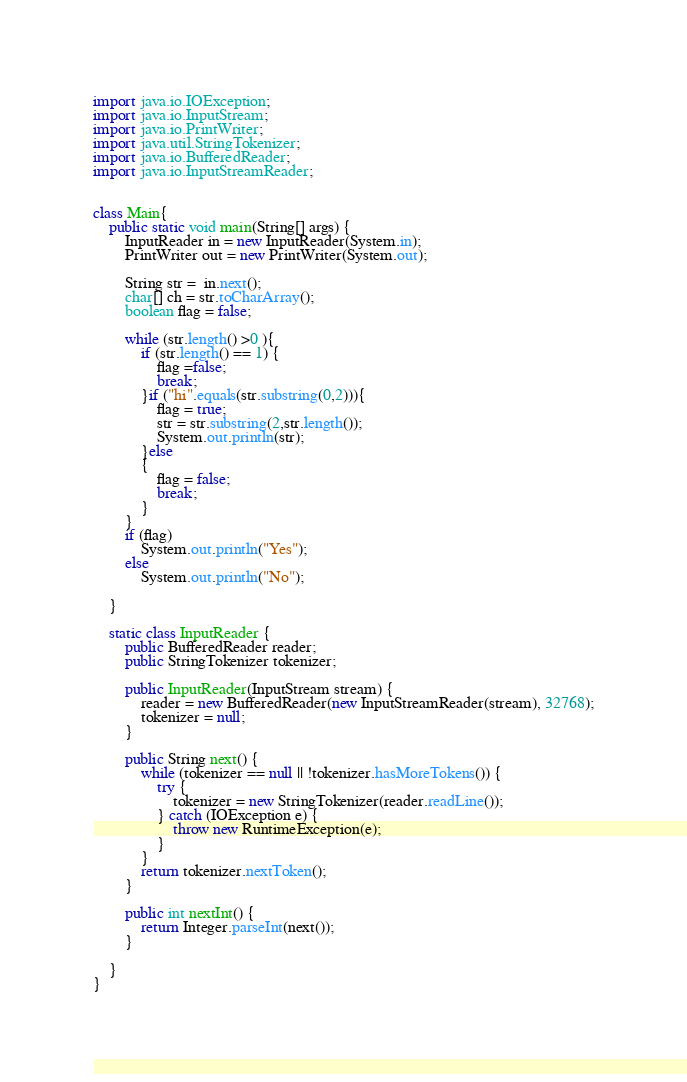<code> <loc_0><loc_0><loc_500><loc_500><_Java_>
import java.io.IOException;
import java.io.InputStream;
import java.io.PrintWriter;
import java.util.StringTokenizer;
import java.io.BufferedReader;
import java.io.InputStreamReader;


class Main{
    public static void main(String[] args) {
        InputReader in = new InputReader(System.in);
        PrintWriter out = new PrintWriter(System.out);

        String str =  in.next();
        char[] ch = str.toCharArray();
        boolean flag = false;

        while (str.length() >0 ){
            if (str.length() == 1) {
                flag =false;
                break;
            }if ("hi".equals(str.substring(0,2))){
                flag = true;
                str = str.substring(2,str.length());
                System.out.println(str);
            }else
            {
                flag = false;
                break;
            }
        }
        if (flag)
            System.out.println("Yes");
        else
            System.out.println("No");

    }

    static class InputReader {
        public BufferedReader reader;
        public StringTokenizer tokenizer;

        public InputReader(InputStream stream) {
            reader = new BufferedReader(new InputStreamReader(stream), 32768);
            tokenizer = null;
        }

        public String next() {
            while (tokenizer == null || !tokenizer.hasMoreTokens()) {
                try {
                    tokenizer = new StringTokenizer(reader.readLine());
                } catch (IOException e) {
                    throw new RuntimeException(e);
                }
            }
            return tokenizer.nextToken();
        }

        public int nextInt() {
            return Integer.parseInt(next());
        }

    }
}
</code> 